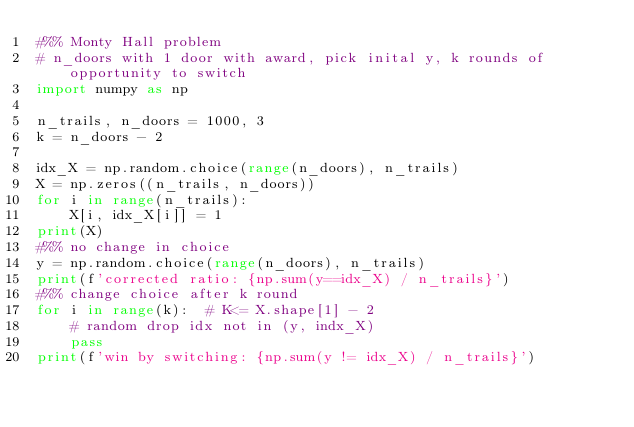<code> <loc_0><loc_0><loc_500><loc_500><_Python_>#%% Monty Hall problem
# n_doors with 1 door with award, pick inital y, k rounds of opportunity to switch
import numpy as np

n_trails, n_doors = 1000, 3
k = n_doors - 2

idx_X = np.random.choice(range(n_doors), n_trails)
X = np.zeros((n_trails, n_doors))
for i in range(n_trails):
    X[i, idx_X[i]] = 1
print(X)
#%% no change in choice
y = np.random.choice(range(n_doors), n_trails)
print(f'corrected ratio: {np.sum(y==idx_X) / n_trails}')
#%% change choice after k round
for i in range(k):  # K<= X.shape[1] - 2
    # random drop idx not in (y, indx_X)
    pass
print(f'win by switching: {np.sum(y != idx_X) / n_trails}')


</code> 